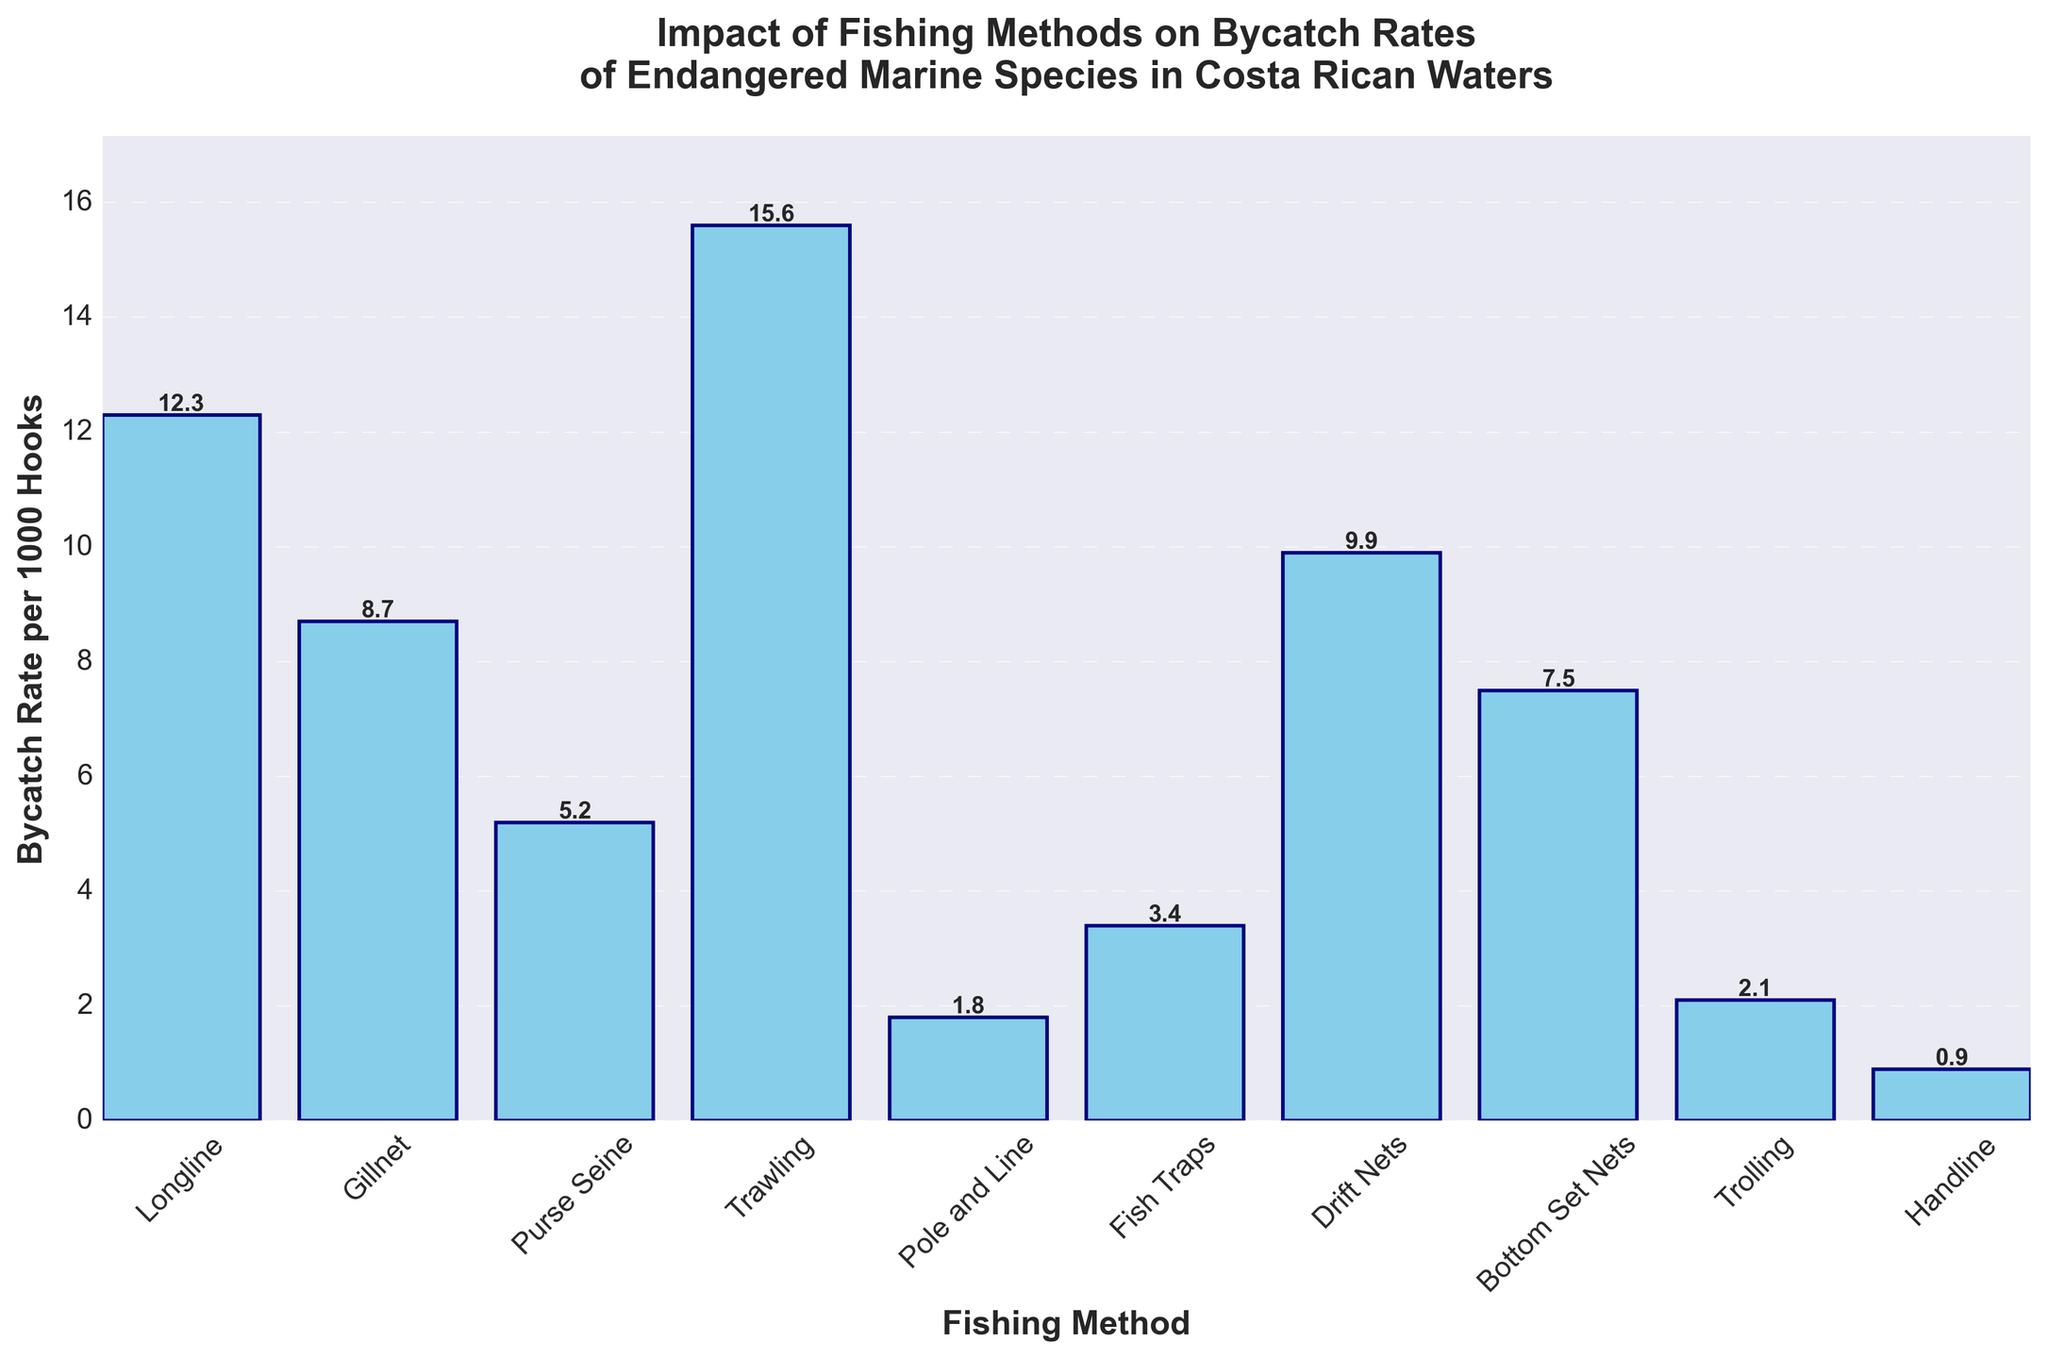Which fishing method has the highest bycatch rate? The bar for Trawling is the tallest, indicating it has the highest bycatch rate.
Answer: Trawling Which fishing method has the lowest bycatch rate? The bar for Handline is the shortest, which means it has the lowest bycatch rate.
Answer: Handline What is the bycatch rate of Gillnet fishing? The bar for Gillnet is labeled with a height of 8.7, indiating its bycatch rate.
Answer: 8.7 How much higher is the bycatch rate for Trawling compared to Pole and Line? The bycatch rate for Trawling is 15.6 and for Pole and Line it is 1.8. Subtracting these: 15.6 - 1.8 = 13.8.
Answer: 13.8 What is the average bycatch rate across all fishing methods? Sum of all bycatch rates: 12.3 + 8.7 + 5.2 + 15.6 + 1.8 + 3.4 + 9.9 + 7.5 + 2.1 + 0.9 = 67.4. There are 10 methods, so average = 67.4 / 10 = 6.74.
Answer: 6.74 Which two fishing methods have the most similar bycatch rates, and what are their rates? Comparing the heights of all bars, Bottom Set Nets (7.5) and Gillnet (8.7) are the closest in value.
Answer: Bottom Set Nets (7.5) and Gillnet (8.7) How many fishing methods have a bycatch rate lower than 5 per 1000 hooks? Bycatch rates lower than 5: Pole and Line (1.8), Fish Traps (3.4), Trolling (2.1), Handline (0.9). There are 4 methods.
Answer: 4 What is the total bycatch rate for all methods combined? Sum of the bycatch rates: 12.3 + 8.7 + 5.2 + 15.6 + 1.8 + 3.4 + 9.9 + 7.5 + 2.1 + 0.9 = 67.4.
Answer: 67.4 Is the bycatch rate of Drift Nets higher or lower than the average bycatch rate? Drift Nets' rate is 9.9. The average rate is 6.74. Since 9.9 > 6.74, Drift Nets has a higher rate.
Answer: Higher 